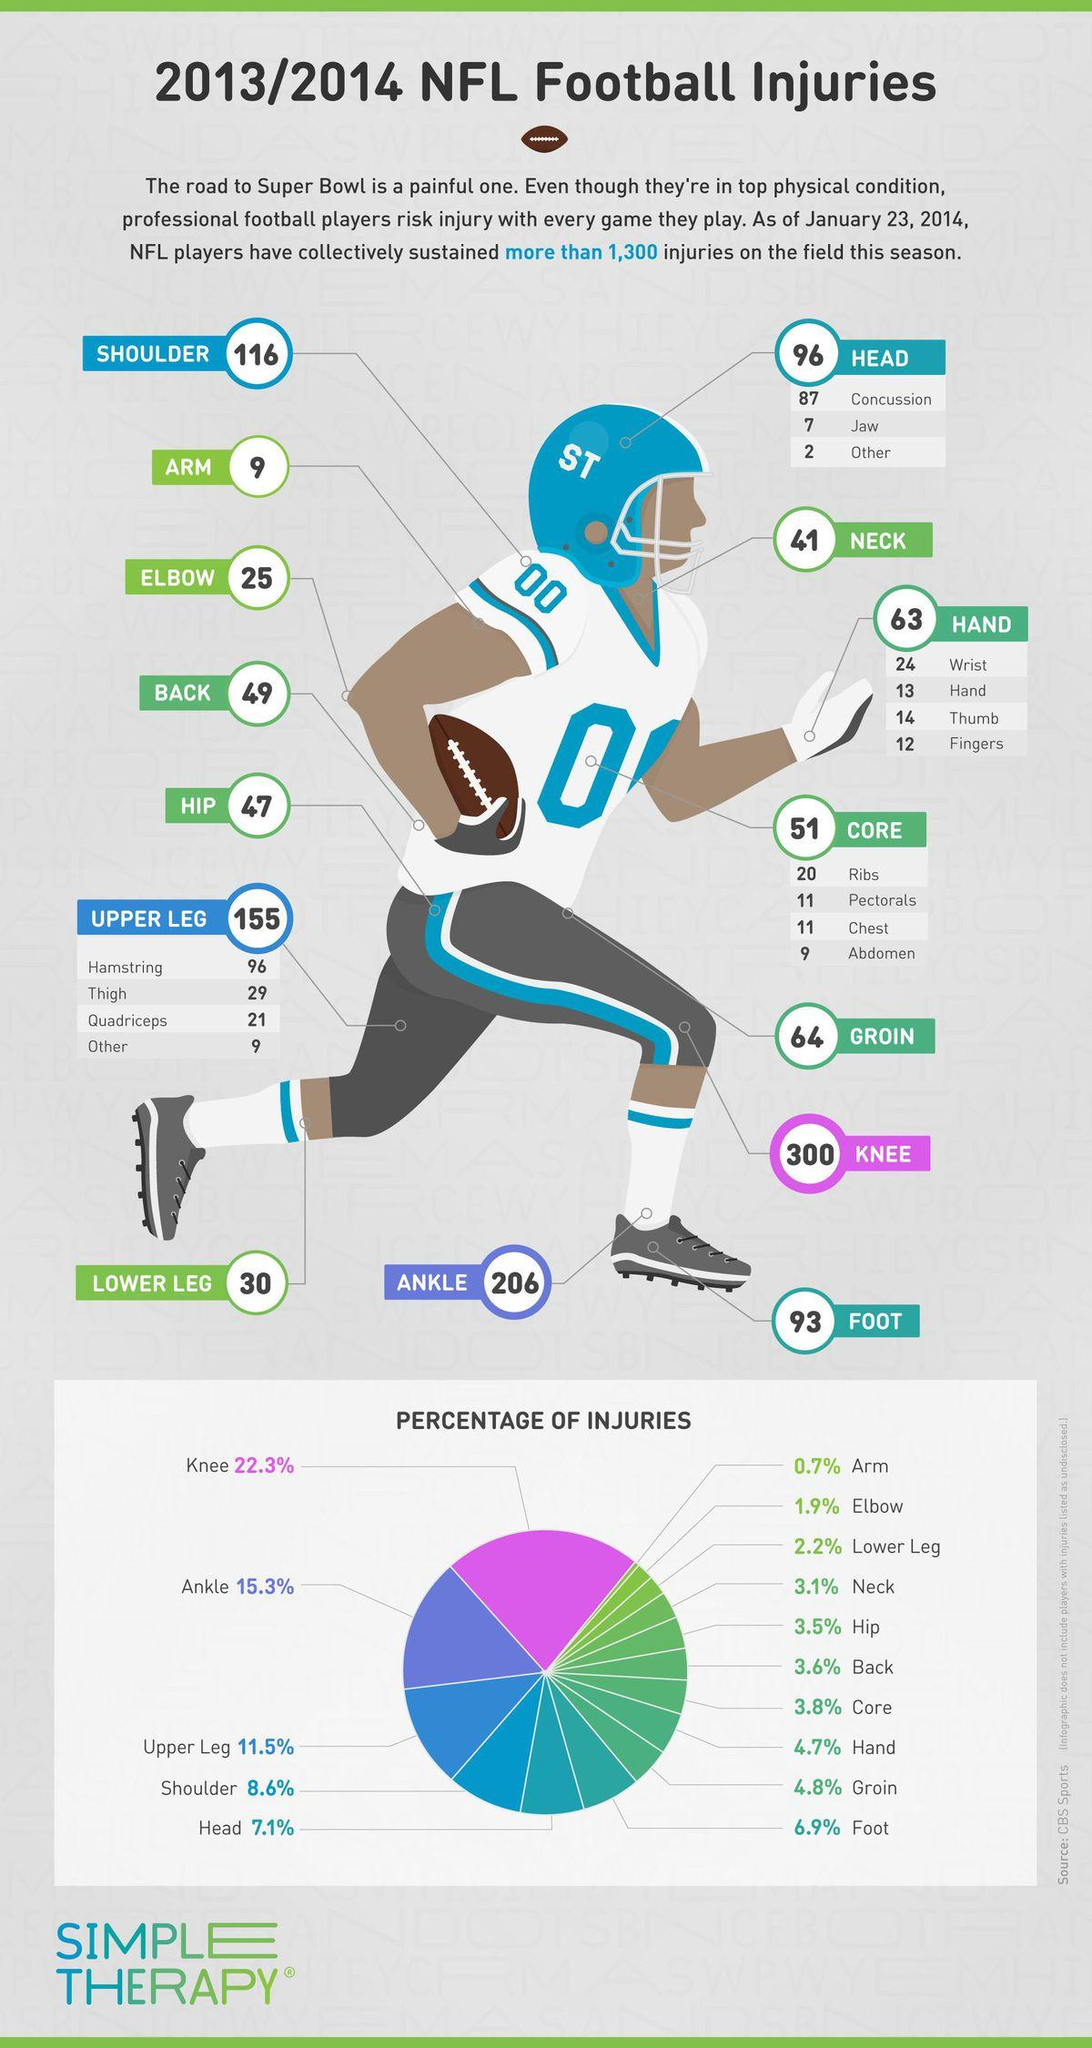Indicate a few pertinent items in this graphic. The helmet of the player shown in the image is blue in color. The majority of respondents reported that their knees were the body part most frequently injured. According to the data, 46.7% of injuries occur from the knee down, including the knee itself. Injuries that occur in the neck region and above constitute 10.2% of all reported injuries. 